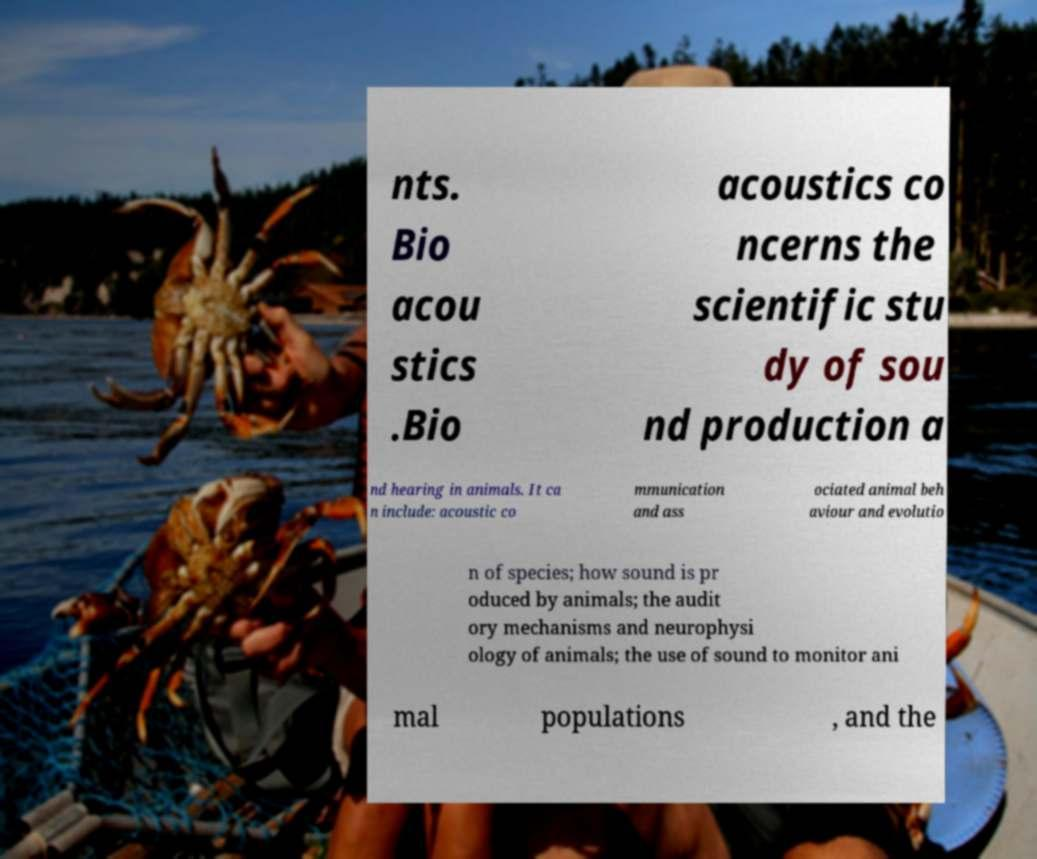Please read and relay the text visible in this image. What does it say? nts. Bio acou stics .Bio acoustics co ncerns the scientific stu dy of sou nd production a nd hearing in animals. It ca n include: acoustic co mmunication and ass ociated animal beh aviour and evolutio n of species; how sound is pr oduced by animals; the audit ory mechanisms and neurophysi ology of animals; the use of sound to monitor ani mal populations , and the 